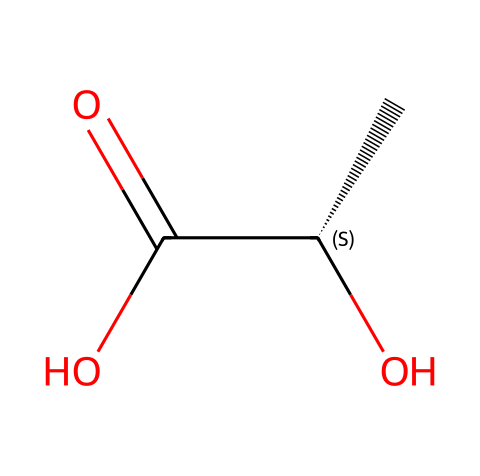how many carbon atoms are in lactic acid? The SMILES representation shows a total of three carbon atoms represented by "C[C@H]", where "C" indicates carbon, hence there are 3 carbon atoms.
Answer: 3 what type of functional group is present in lactic acid? The chemical structure contains a carboxylic acid group, as indicated by "C(=O)O", which specifically denotes the presence of -COOH.
Answer: carboxylic acid does lactic acid have chiral centers? The structure includes a chiral center indicated by "[C@H]", which means one of the carbon atoms is attached to four different substituents, making it a chiral compound.
Answer: yes what is the significance of the chiral center in lactic acid? The chiral center is significant because it leads to the existence of enantiomers, which can display different properties in biological systems, impacting how an athlete metabolizes lactic acid during exertion.
Answer: enantiomers what is the molecular formula of lactic acid? By analyzing the structure, we see it consists of 3 carbon atoms, 6 hydrogen atoms, and 3 oxygen atoms, leading to the formula C3H6O3.
Answer: C3H6O3 